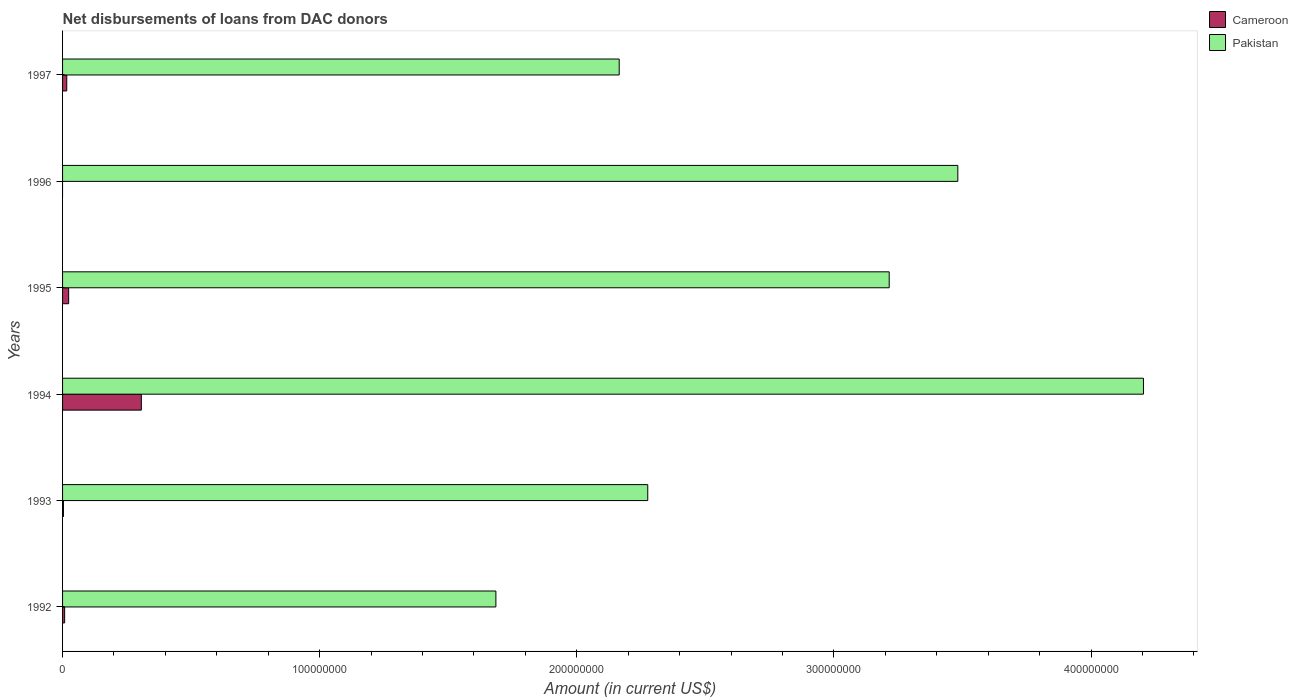Are the number of bars per tick equal to the number of legend labels?
Give a very brief answer. No. How many bars are there on the 2nd tick from the top?
Ensure brevity in your answer.  1. How many bars are there on the 3rd tick from the bottom?
Give a very brief answer. 2. What is the label of the 4th group of bars from the top?
Provide a short and direct response. 1994. In how many cases, is the number of bars for a given year not equal to the number of legend labels?
Your response must be concise. 1. What is the amount of loans disbursed in Cameroon in 1992?
Your response must be concise. 8.08e+05. Across all years, what is the maximum amount of loans disbursed in Pakistan?
Keep it short and to the point. 4.20e+08. Across all years, what is the minimum amount of loans disbursed in Pakistan?
Your response must be concise. 1.69e+08. In which year was the amount of loans disbursed in Cameroon maximum?
Ensure brevity in your answer.  1994. What is the total amount of loans disbursed in Pakistan in the graph?
Provide a short and direct response. 1.70e+09. What is the difference between the amount of loans disbursed in Pakistan in 1994 and that in 1997?
Make the answer very short. 2.04e+08. What is the difference between the amount of loans disbursed in Cameroon in 1993 and the amount of loans disbursed in Pakistan in 1997?
Provide a short and direct response. -2.16e+08. What is the average amount of loans disbursed in Cameroon per year?
Your response must be concise. 5.96e+06. In the year 1995, what is the difference between the amount of loans disbursed in Pakistan and amount of loans disbursed in Cameroon?
Keep it short and to the point. 3.19e+08. What is the ratio of the amount of loans disbursed in Cameroon in 1994 to that in 1997?
Keep it short and to the point. 18.82. Is the amount of loans disbursed in Pakistan in 1992 less than that in 1996?
Your answer should be very brief. Yes. What is the difference between the highest and the second highest amount of loans disbursed in Pakistan?
Your response must be concise. 7.22e+07. What is the difference between the highest and the lowest amount of loans disbursed in Cameroon?
Ensure brevity in your answer.  3.06e+07. In how many years, is the amount of loans disbursed in Cameroon greater than the average amount of loans disbursed in Cameroon taken over all years?
Provide a succinct answer. 1. Is the sum of the amount of loans disbursed in Cameroon in 1993 and 1995 greater than the maximum amount of loans disbursed in Pakistan across all years?
Keep it short and to the point. No. How many bars are there?
Provide a short and direct response. 11. Are all the bars in the graph horizontal?
Your answer should be very brief. Yes. What is the difference between two consecutive major ticks on the X-axis?
Give a very brief answer. 1.00e+08. Are the values on the major ticks of X-axis written in scientific E-notation?
Ensure brevity in your answer.  No. Where does the legend appear in the graph?
Provide a short and direct response. Top right. How many legend labels are there?
Keep it short and to the point. 2. What is the title of the graph?
Keep it short and to the point. Net disbursements of loans from DAC donors. What is the label or title of the X-axis?
Ensure brevity in your answer.  Amount (in current US$). What is the Amount (in current US$) of Cameroon in 1992?
Your answer should be compact. 8.08e+05. What is the Amount (in current US$) in Pakistan in 1992?
Provide a short and direct response. 1.69e+08. What is the Amount (in current US$) of Pakistan in 1993?
Offer a very short reply. 2.28e+08. What is the Amount (in current US$) in Cameroon in 1994?
Offer a terse response. 3.06e+07. What is the Amount (in current US$) in Pakistan in 1994?
Your answer should be very brief. 4.20e+08. What is the Amount (in current US$) in Cameroon in 1995?
Offer a very short reply. 2.37e+06. What is the Amount (in current US$) in Pakistan in 1995?
Ensure brevity in your answer.  3.21e+08. What is the Amount (in current US$) in Cameroon in 1996?
Keep it short and to the point. 0. What is the Amount (in current US$) in Pakistan in 1996?
Your answer should be very brief. 3.48e+08. What is the Amount (in current US$) in Cameroon in 1997?
Offer a very short reply. 1.63e+06. What is the Amount (in current US$) of Pakistan in 1997?
Your answer should be compact. 2.16e+08. Across all years, what is the maximum Amount (in current US$) of Cameroon?
Give a very brief answer. 3.06e+07. Across all years, what is the maximum Amount (in current US$) of Pakistan?
Keep it short and to the point. 4.20e+08. Across all years, what is the minimum Amount (in current US$) of Pakistan?
Provide a short and direct response. 1.69e+08. What is the total Amount (in current US$) of Cameroon in the graph?
Ensure brevity in your answer.  3.58e+07. What is the total Amount (in current US$) of Pakistan in the graph?
Ensure brevity in your answer.  1.70e+09. What is the difference between the Amount (in current US$) of Cameroon in 1992 and that in 1993?
Provide a succinct answer. 4.68e+05. What is the difference between the Amount (in current US$) in Pakistan in 1992 and that in 1993?
Your response must be concise. -5.91e+07. What is the difference between the Amount (in current US$) of Cameroon in 1992 and that in 1994?
Give a very brief answer. -2.98e+07. What is the difference between the Amount (in current US$) in Pakistan in 1992 and that in 1994?
Ensure brevity in your answer.  -2.52e+08. What is the difference between the Amount (in current US$) in Cameroon in 1992 and that in 1995?
Ensure brevity in your answer.  -1.56e+06. What is the difference between the Amount (in current US$) of Pakistan in 1992 and that in 1995?
Your response must be concise. -1.53e+08. What is the difference between the Amount (in current US$) of Pakistan in 1992 and that in 1996?
Your answer should be very brief. -1.80e+08. What is the difference between the Amount (in current US$) of Cameroon in 1992 and that in 1997?
Ensure brevity in your answer.  -8.20e+05. What is the difference between the Amount (in current US$) in Pakistan in 1992 and that in 1997?
Offer a terse response. -4.80e+07. What is the difference between the Amount (in current US$) of Cameroon in 1993 and that in 1994?
Offer a very short reply. -3.03e+07. What is the difference between the Amount (in current US$) of Pakistan in 1993 and that in 1994?
Your response must be concise. -1.93e+08. What is the difference between the Amount (in current US$) in Cameroon in 1993 and that in 1995?
Offer a terse response. -2.03e+06. What is the difference between the Amount (in current US$) of Pakistan in 1993 and that in 1995?
Make the answer very short. -9.39e+07. What is the difference between the Amount (in current US$) in Pakistan in 1993 and that in 1996?
Offer a very short reply. -1.21e+08. What is the difference between the Amount (in current US$) in Cameroon in 1993 and that in 1997?
Your answer should be very brief. -1.29e+06. What is the difference between the Amount (in current US$) of Pakistan in 1993 and that in 1997?
Offer a terse response. 1.11e+07. What is the difference between the Amount (in current US$) of Cameroon in 1994 and that in 1995?
Provide a succinct answer. 2.83e+07. What is the difference between the Amount (in current US$) of Pakistan in 1994 and that in 1995?
Your response must be concise. 9.89e+07. What is the difference between the Amount (in current US$) in Pakistan in 1994 and that in 1996?
Your response must be concise. 7.22e+07. What is the difference between the Amount (in current US$) of Cameroon in 1994 and that in 1997?
Keep it short and to the point. 2.90e+07. What is the difference between the Amount (in current US$) of Pakistan in 1994 and that in 1997?
Your answer should be compact. 2.04e+08. What is the difference between the Amount (in current US$) of Pakistan in 1995 and that in 1996?
Make the answer very short. -2.67e+07. What is the difference between the Amount (in current US$) of Cameroon in 1995 and that in 1997?
Ensure brevity in your answer.  7.40e+05. What is the difference between the Amount (in current US$) in Pakistan in 1995 and that in 1997?
Ensure brevity in your answer.  1.05e+08. What is the difference between the Amount (in current US$) in Pakistan in 1996 and that in 1997?
Keep it short and to the point. 1.32e+08. What is the difference between the Amount (in current US$) of Cameroon in 1992 and the Amount (in current US$) of Pakistan in 1993?
Provide a succinct answer. -2.27e+08. What is the difference between the Amount (in current US$) in Cameroon in 1992 and the Amount (in current US$) in Pakistan in 1994?
Your answer should be very brief. -4.20e+08. What is the difference between the Amount (in current US$) in Cameroon in 1992 and the Amount (in current US$) in Pakistan in 1995?
Your answer should be very brief. -3.21e+08. What is the difference between the Amount (in current US$) in Cameroon in 1992 and the Amount (in current US$) in Pakistan in 1996?
Ensure brevity in your answer.  -3.47e+08. What is the difference between the Amount (in current US$) in Cameroon in 1992 and the Amount (in current US$) in Pakistan in 1997?
Give a very brief answer. -2.16e+08. What is the difference between the Amount (in current US$) in Cameroon in 1993 and the Amount (in current US$) in Pakistan in 1994?
Your answer should be compact. -4.20e+08. What is the difference between the Amount (in current US$) in Cameroon in 1993 and the Amount (in current US$) in Pakistan in 1995?
Make the answer very short. -3.21e+08. What is the difference between the Amount (in current US$) in Cameroon in 1993 and the Amount (in current US$) in Pakistan in 1996?
Your answer should be very brief. -3.48e+08. What is the difference between the Amount (in current US$) of Cameroon in 1993 and the Amount (in current US$) of Pakistan in 1997?
Offer a terse response. -2.16e+08. What is the difference between the Amount (in current US$) in Cameroon in 1994 and the Amount (in current US$) in Pakistan in 1995?
Your response must be concise. -2.91e+08. What is the difference between the Amount (in current US$) in Cameroon in 1994 and the Amount (in current US$) in Pakistan in 1996?
Your answer should be very brief. -3.18e+08. What is the difference between the Amount (in current US$) in Cameroon in 1994 and the Amount (in current US$) in Pakistan in 1997?
Keep it short and to the point. -1.86e+08. What is the difference between the Amount (in current US$) of Cameroon in 1995 and the Amount (in current US$) of Pakistan in 1996?
Provide a succinct answer. -3.46e+08. What is the difference between the Amount (in current US$) in Cameroon in 1995 and the Amount (in current US$) in Pakistan in 1997?
Offer a very short reply. -2.14e+08. What is the average Amount (in current US$) in Cameroon per year?
Provide a short and direct response. 5.96e+06. What is the average Amount (in current US$) of Pakistan per year?
Offer a terse response. 2.84e+08. In the year 1992, what is the difference between the Amount (in current US$) of Cameroon and Amount (in current US$) of Pakistan?
Provide a short and direct response. -1.68e+08. In the year 1993, what is the difference between the Amount (in current US$) of Cameroon and Amount (in current US$) of Pakistan?
Your answer should be very brief. -2.27e+08. In the year 1994, what is the difference between the Amount (in current US$) in Cameroon and Amount (in current US$) in Pakistan?
Keep it short and to the point. -3.90e+08. In the year 1995, what is the difference between the Amount (in current US$) in Cameroon and Amount (in current US$) in Pakistan?
Provide a succinct answer. -3.19e+08. In the year 1997, what is the difference between the Amount (in current US$) of Cameroon and Amount (in current US$) of Pakistan?
Offer a terse response. -2.15e+08. What is the ratio of the Amount (in current US$) of Cameroon in 1992 to that in 1993?
Keep it short and to the point. 2.38. What is the ratio of the Amount (in current US$) of Pakistan in 1992 to that in 1993?
Your answer should be compact. 0.74. What is the ratio of the Amount (in current US$) in Cameroon in 1992 to that in 1994?
Give a very brief answer. 0.03. What is the ratio of the Amount (in current US$) in Pakistan in 1992 to that in 1994?
Give a very brief answer. 0.4. What is the ratio of the Amount (in current US$) of Cameroon in 1992 to that in 1995?
Your answer should be compact. 0.34. What is the ratio of the Amount (in current US$) of Pakistan in 1992 to that in 1995?
Your answer should be very brief. 0.52. What is the ratio of the Amount (in current US$) in Pakistan in 1992 to that in 1996?
Give a very brief answer. 0.48. What is the ratio of the Amount (in current US$) in Cameroon in 1992 to that in 1997?
Offer a terse response. 0.5. What is the ratio of the Amount (in current US$) in Pakistan in 1992 to that in 1997?
Give a very brief answer. 0.78. What is the ratio of the Amount (in current US$) of Cameroon in 1993 to that in 1994?
Keep it short and to the point. 0.01. What is the ratio of the Amount (in current US$) in Pakistan in 1993 to that in 1994?
Ensure brevity in your answer.  0.54. What is the ratio of the Amount (in current US$) in Cameroon in 1993 to that in 1995?
Make the answer very short. 0.14. What is the ratio of the Amount (in current US$) in Pakistan in 1993 to that in 1995?
Ensure brevity in your answer.  0.71. What is the ratio of the Amount (in current US$) in Pakistan in 1993 to that in 1996?
Your answer should be compact. 0.65. What is the ratio of the Amount (in current US$) of Cameroon in 1993 to that in 1997?
Keep it short and to the point. 0.21. What is the ratio of the Amount (in current US$) in Pakistan in 1993 to that in 1997?
Keep it short and to the point. 1.05. What is the ratio of the Amount (in current US$) in Cameroon in 1994 to that in 1995?
Give a very brief answer. 12.94. What is the ratio of the Amount (in current US$) in Pakistan in 1994 to that in 1995?
Provide a short and direct response. 1.31. What is the ratio of the Amount (in current US$) in Pakistan in 1994 to that in 1996?
Ensure brevity in your answer.  1.21. What is the ratio of the Amount (in current US$) of Cameroon in 1994 to that in 1997?
Your answer should be very brief. 18.82. What is the ratio of the Amount (in current US$) in Pakistan in 1994 to that in 1997?
Offer a terse response. 1.94. What is the ratio of the Amount (in current US$) of Pakistan in 1995 to that in 1996?
Your answer should be very brief. 0.92. What is the ratio of the Amount (in current US$) in Cameroon in 1995 to that in 1997?
Give a very brief answer. 1.45. What is the ratio of the Amount (in current US$) in Pakistan in 1995 to that in 1997?
Ensure brevity in your answer.  1.49. What is the ratio of the Amount (in current US$) in Pakistan in 1996 to that in 1997?
Keep it short and to the point. 1.61. What is the difference between the highest and the second highest Amount (in current US$) in Cameroon?
Provide a succinct answer. 2.83e+07. What is the difference between the highest and the second highest Amount (in current US$) of Pakistan?
Keep it short and to the point. 7.22e+07. What is the difference between the highest and the lowest Amount (in current US$) in Cameroon?
Provide a succinct answer. 3.06e+07. What is the difference between the highest and the lowest Amount (in current US$) in Pakistan?
Offer a very short reply. 2.52e+08. 